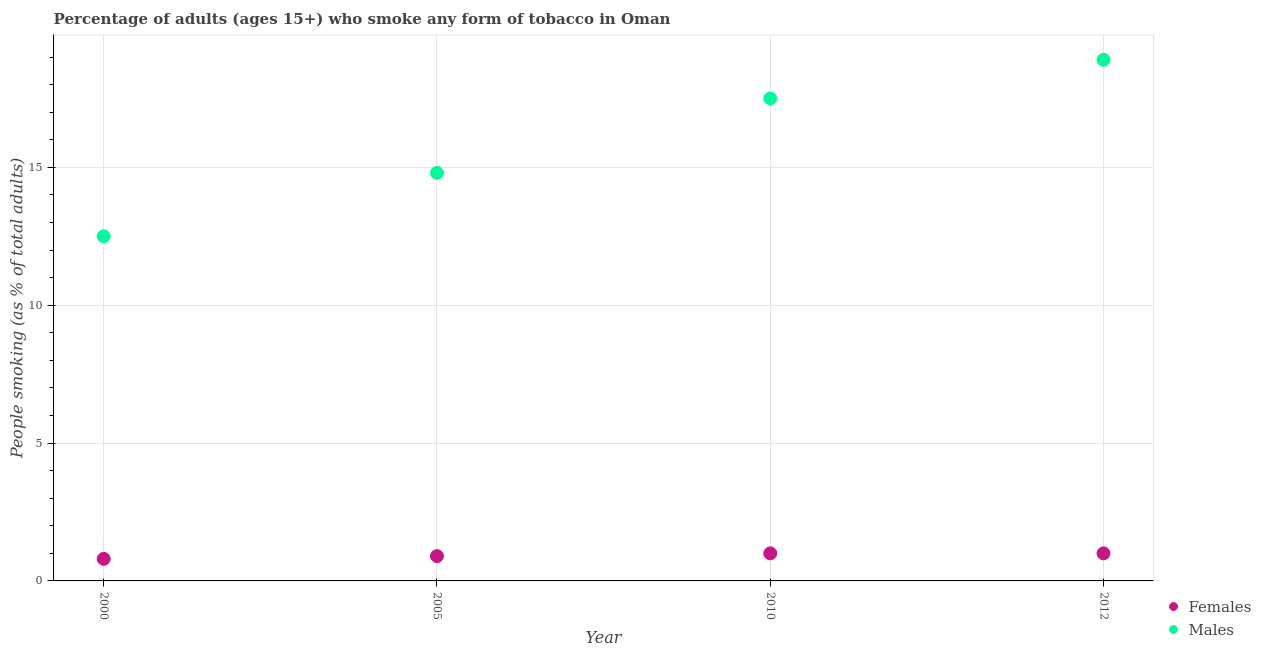What is the percentage of males who smoke in 2000?
Offer a very short reply. 12.5. In which year was the percentage of females who smoke maximum?
Offer a very short reply. 2010. In which year was the percentage of females who smoke minimum?
Your response must be concise. 2000. What is the total percentage of females who smoke in the graph?
Provide a succinct answer. 3.7. What is the difference between the percentage of females who smoke in 2000 and that in 2010?
Your answer should be compact. -0.2. What is the difference between the percentage of females who smoke in 2010 and the percentage of males who smoke in 2012?
Your response must be concise. -17.9. What is the average percentage of males who smoke per year?
Your answer should be very brief. 15.92. In the year 2010, what is the difference between the percentage of females who smoke and percentage of males who smoke?
Offer a terse response. -16.5. In how many years, is the percentage of males who smoke greater than 10 %?
Make the answer very short. 4. Is the percentage of females who smoke in 2010 less than that in 2012?
Offer a very short reply. No. Is the difference between the percentage of males who smoke in 2005 and 2010 greater than the difference between the percentage of females who smoke in 2005 and 2010?
Your answer should be very brief. No. What is the difference between the highest and the lowest percentage of females who smoke?
Give a very brief answer. 0.2. In how many years, is the percentage of females who smoke greater than the average percentage of females who smoke taken over all years?
Provide a short and direct response. 2. Does the percentage of males who smoke monotonically increase over the years?
Your answer should be compact. Yes. Is the percentage of females who smoke strictly greater than the percentage of males who smoke over the years?
Keep it short and to the point. No. Is the percentage of males who smoke strictly less than the percentage of females who smoke over the years?
Offer a terse response. No. How many years are there in the graph?
Your answer should be very brief. 4. What is the difference between two consecutive major ticks on the Y-axis?
Provide a short and direct response. 5. How are the legend labels stacked?
Your answer should be compact. Vertical. What is the title of the graph?
Give a very brief answer. Percentage of adults (ages 15+) who smoke any form of tobacco in Oman. What is the label or title of the Y-axis?
Give a very brief answer. People smoking (as % of total adults). What is the People smoking (as % of total adults) in Females in 2000?
Offer a very short reply. 0.8. What is the People smoking (as % of total adults) in Males in 2000?
Your answer should be very brief. 12.5. What is the People smoking (as % of total adults) of Females in 2005?
Your answer should be compact. 0.9. What is the People smoking (as % of total adults) of Males in 2010?
Provide a succinct answer. 17.5. Across all years, what is the maximum People smoking (as % of total adults) of Females?
Make the answer very short. 1. Across all years, what is the maximum People smoking (as % of total adults) in Males?
Provide a short and direct response. 18.9. Across all years, what is the minimum People smoking (as % of total adults) of Females?
Make the answer very short. 0.8. Across all years, what is the minimum People smoking (as % of total adults) in Males?
Provide a short and direct response. 12.5. What is the total People smoking (as % of total adults) of Females in the graph?
Offer a terse response. 3.7. What is the total People smoking (as % of total adults) in Males in the graph?
Your response must be concise. 63.7. What is the difference between the People smoking (as % of total adults) of Females in 2000 and that in 2005?
Offer a terse response. -0.1. What is the difference between the People smoking (as % of total adults) in Females in 2000 and that in 2010?
Keep it short and to the point. -0.2. What is the difference between the People smoking (as % of total adults) of Females in 2005 and that in 2010?
Give a very brief answer. -0.1. What is the difference between the People smoking (as % of total adults) in Males in 2005 and that in 2010?
Your answer should be compact. -2.7. What is the difference between the People smoking (as % of total adults) in Females in 2005 and that in 2012?
Offer a terse response. -0.1. What is the difference between the People smoking (as % of total adults) of Males in 2005 and that in 2012?
Your answer should be very brief. -4.1. What is the difference between the People smoking (as % of total adults) of Males in 2010 and that in 2012?
Your answer should be compact. -1.4. What is the difference between the People smoking (as % of total adults) of Females in 2000 and the People smoking (as % of total adults) of Males in 2005?
Give a very brief answer. -14. What is the difference between the People smoking (as % of total adults) of Females in 2000 and the People smoking (as % of total adults) of Males in 2010?
Provide a succinct answer. -16.7. What is the difference between the People smoking (as % of total adults) of Females in 2000 and the People smoking (as % of total adults) of Males in 2012?
Your response must be concise. -18.1. What is the difference between the People smoking (as % of total adults) in Females in 2005 and the People smoking (as % of total adults) in Males in 2010?
Make the answer very short. -16.6. What is the difference between the People smoking (as % of total adults) of Females in 2010 and the People smoking (as % of total adults) of Males in 2012?
Provide a succinct answer. -17.9. What is the average People smoking (as % of total adults) of Females per year?
Your answer should be compact. 0.93. What is the average People smoking (as % of total adults) in Males per year?
Your answer should be very brief. 15.93. In the year 2005, what is the difference between the People smoking (as % of total adults) of Females and People smoking (as % of total adults) of Males?
Keep it short and to the point. -13.9. In the year 2010, what is the difference between the People smoking (as % of total adults) in Females and People smoking (as % of total adults) in Males?
Give a very brief answer. -16.5. In the year 2012, what is the difference between the People smoking (as % of total adults) of Females and People smoking (as % of total adults) of Males?
Your answer should be compact. -17.9. What is the ratio of the People smoking (as % of total adults) in Females in 2000 to that in 2005?
Provide a succinct answer. 0.89. What is the ratio of the People smoking (as % of total adults) of Males in 2000 to that in 2005?
Your response must be concise. 0.84. What is the ratio of the People smoking (as % of total adults) in Females in 2000 to that in 2010?
Provide a succinct answer. 0.8. What is the ratio of the People smoking (as % of total adults) in Males in 2000 to that in 2010?
Make the answer very short. 0.71. What is the ratio of the People smoking (as % of total adults) of Males in 2000 to that in 2012?
Keep it short and to the point. 0.66. What is the ratio of the People smoking (as % of total adults) of Females in 2005 to that in 2010?
Provide a short and direct response. 0.9. What is the ratio of the People smoking (as % of total adults) in Males in 2005 to that in 2010?
Offer a very short reply. 0.85. What is the ratio of the People smoking (as % of total adults) of Males in 2005 to that in 2012?
Offer a terse response. 0.78. What is the ratio of the People smoking (as % of total adults) of Females in 2010 to that in 2012?
Your response must be concise. 1. What is the ratio of the People smoking (as % of total adults) in Males in 2010 to that in 2012?
Provide a succinct answer. 0.93. What is the difference between the highest and the second highest People smoking (as % of total adults) of Females?
Make the answer very short. 0. What is the difference between the highest and the lowest People smoking (as % of total adults) of Females?
Your answer should be compact. 0.2. What is the difference between the highest and the lowest People smoking (as % of total adults) of Males?
Your answer should be compact. 6.4. 